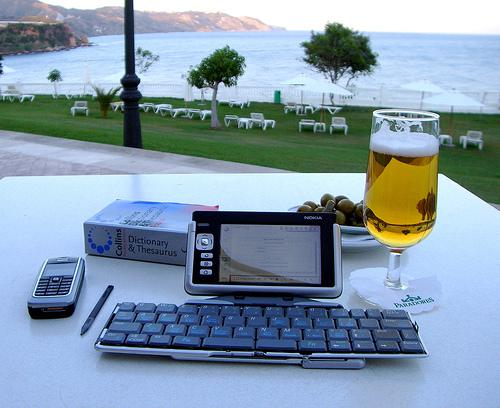Question: where was this photo taken?
Choices:
A. Seaside.
B. At a baseball game.
C. At the beach.
D. At the bus station.
Answer with the letter. Answer: A Question: how would the computer monitor shown here operate?
Choices:
A. By keyboard.
B. By mouse.
C. By voice.
D. By remote control.
Answer with the letter. Answer: A Question: when for one would a person use the computer?
Choices:
A. To play games.
B. To work.
C. To research.
D. To talk with friends.
Answer with the letter. Answer: A Question: what color is the beer?
Choices:
A. Yellow.
B. Amber.
C. Beige.
D. Clear.
Answer with the letter. Answer: B 